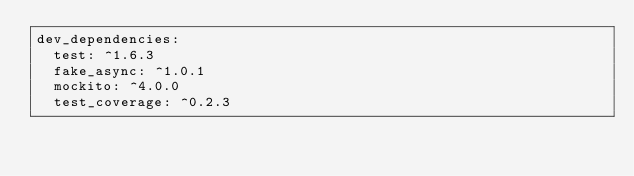Convert code to text. <code><loc_0><loc_0><loc_500><loc_500><_YAML_>dev_dependencies:
  test: ^1.6.3
  fake_async: ^1.0.1
  mockito: ^4.0.0
  test_coverage: ^0.2.3
</code> 